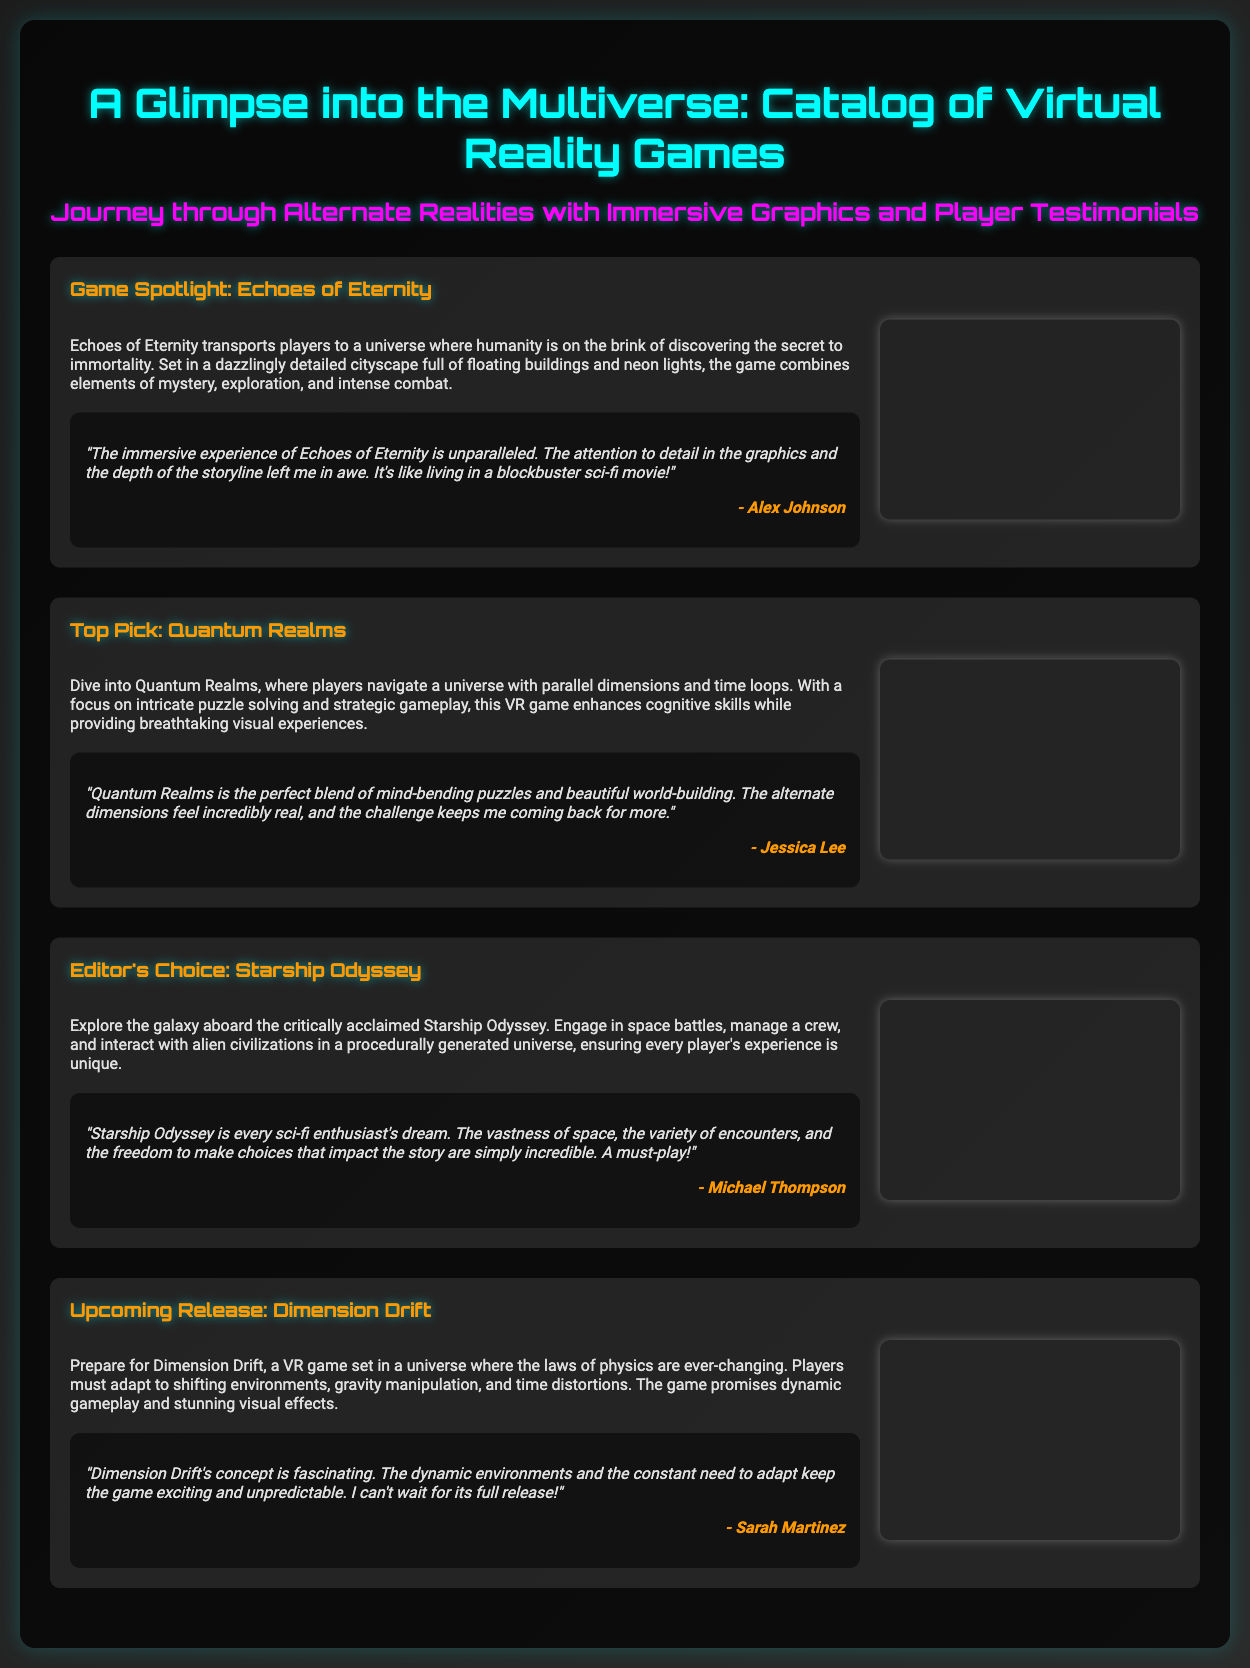What is the title of the catalog? The title of the catalog is prominently displayed at the top of the document as “A Glimpse into the Multiverse: Catalog of Virtual Reality Games.”
Answer: A Glimpse into the Multiverse: Catalog of Virtual Reality Games How many games are featured in the document? The document showcases a total of four games, which are highlighted in separate sections.
Answer: Four What is the name of the game featured in the “Upcoming Release” section? The document includes a dedicated section for an upcoming release named “Dimension Drift.”
Answer: Dimension Drift Which game emphasizes puzzle solving and strategic gameplay? The description for the “Top Pick” game states that it focuses on intricate puzzle solving and strategic gameplay, referring to “Quantum Realms.”
Answer: Quantum Realms Who provided a testimonial for "Starship Odyssey"? The testimonial at the bottom of the “Starship Odyssey” game section is authored by "Michael Thompson."
Answer: Michael Thompson What theme is prevalent in "Echoes of Eternity"? The document describes "Echoes of Eternity" as having themes of mystery, exploration, and intense combat.
Answer: Mystery, exploration, and intense combat Which game has a testimonial mentioning a "blockbuster sci-fi movie"? The testimonial in the "Echoes of Eternity" section describes it as an experience akin to living in a "blockbuster sci-fi movie."
Answer: Echoes of Eternity What feature makes "Dimension Drift" unique compared to other games? The document mentions that “Dimension Drift” is characterized by ever-changing laws of physics, which affects gameplay.
Answer: Ever-changing laws of physics What aspect of "Quantum Realms" does the testimonial highlight? The testimonial for "Quantum Realms" highlights the blend of mind-bending puzzles and beautiful world-building.
Answer: Mind-bending puzzles and beautiful world-building 